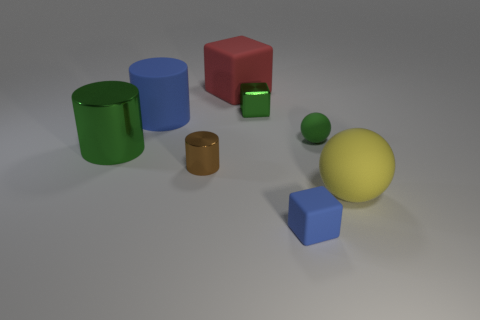Subtract all large green cylinders. How many cylinders are left? 2 Subtract 1 cylinders. How many cylinders are left? 2 Add 2 small metal objects. How many objects exist? 10 Subtract all green cylinders. How many cylinders are left? 2 Subtract all blocks. How many objects are left? 5 Add 8 big yellow things. How many big yellow things are left? 9 Add 7 brown metallic cylinders. How many brown metallic cylinders exist? 8 Subtract 0 gray cylinders. How many objects are left? 8 Subtract all gray cylinders. Subtract all purple cubes. How many cylinders are left? 3 Subtract all purple cylinders. How many red cubes are left? 1 